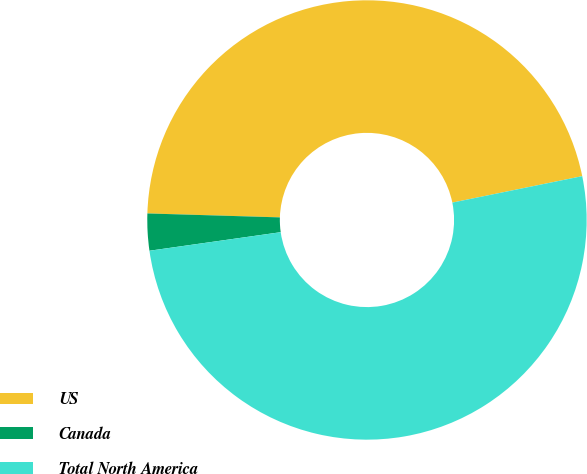<chart> <loc_0><loc_0><loc_500><loc_500><pie_chart><fcel>US<fcel>Canada<fcel>Total North America<nl><fcel>46.33%<fcel>2.71%<fcel>50.96%<nl></chart> 